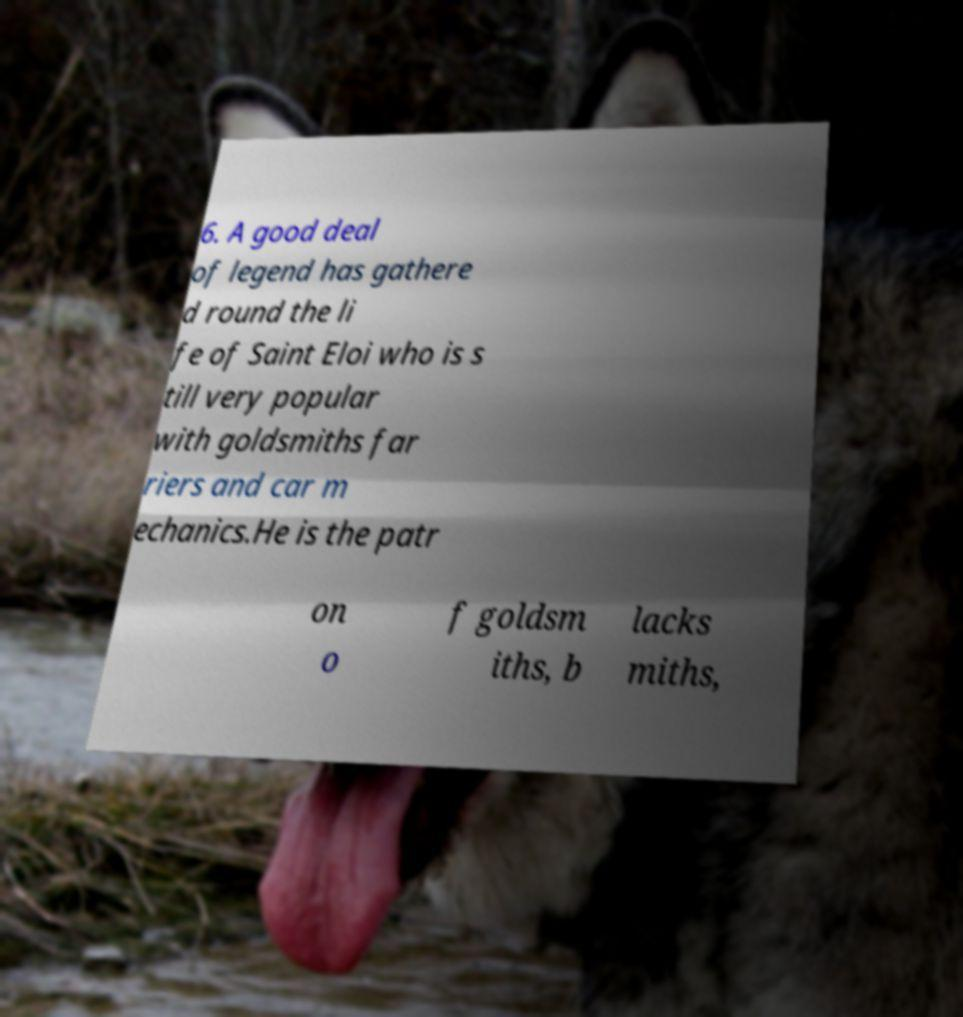Could you assist in decoding the text presented in this image and type it out clearly? 6. A good deal of legend has gathere d round the li fe of Saint Eloi who is s till very popular with goldsmiths far riers and car m echanics.He is the patr on o f goldsm iths, b lacks miths, 